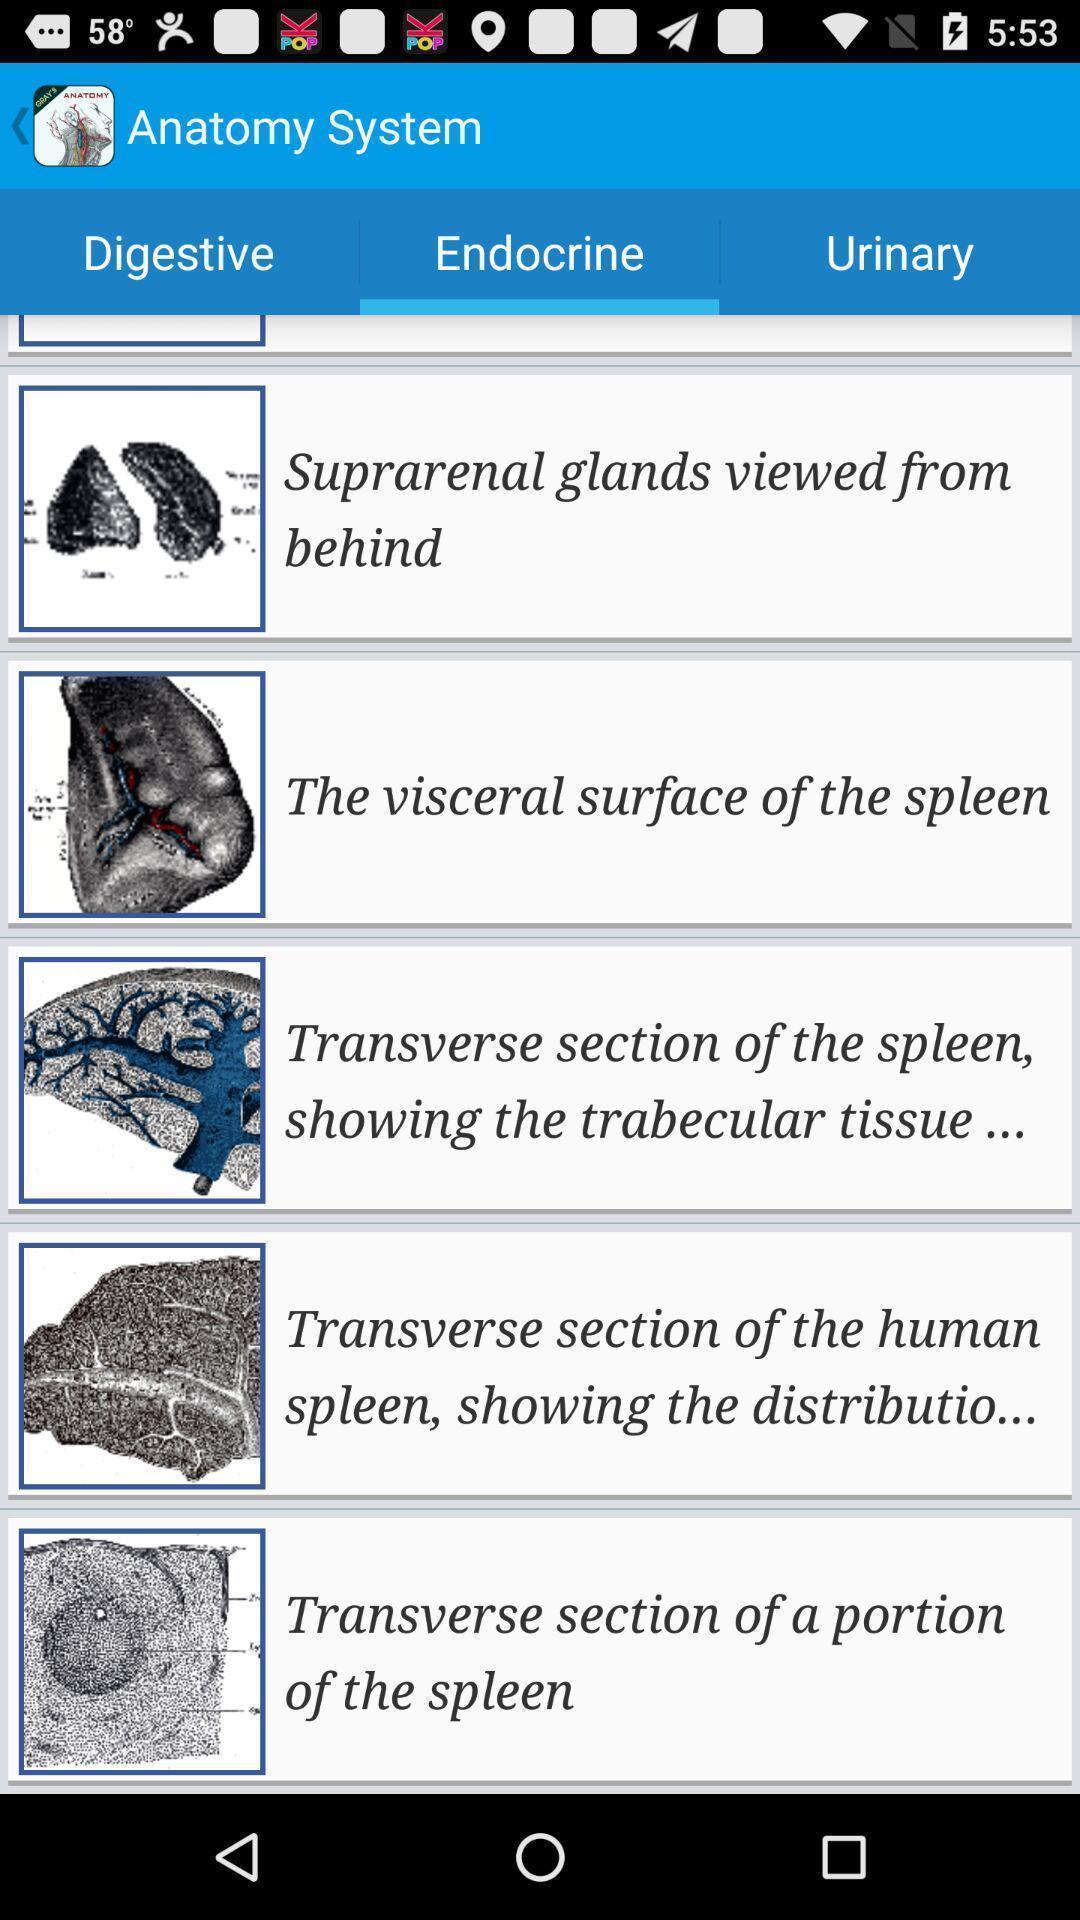Describe the visual elements of this screenshot. Screen showing the options in endocrine tab. 